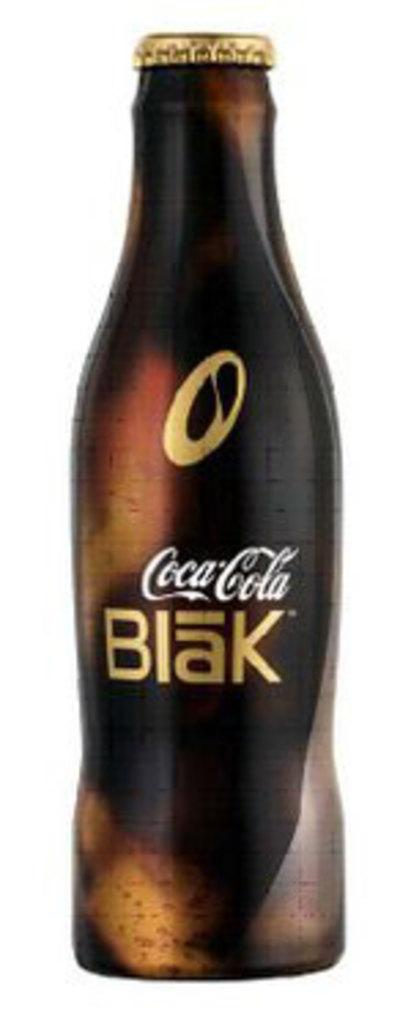<image>
Relay a brief, clear account of the picture shown. a dark brown bottle of Coca Cola Blak 